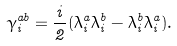Convert formula to latex. <formula><loc_0><loc_0><loc_500><loc_500>\gamma ^ { a b } _ { i } = \frac { i } { 2 } ( \lambda ^ { a } _ { i } \lambda ^ { b } _ { i } - \lambda ^ { b } _ { i } \lambda ^ { a } _ { i } ) .</formula> 